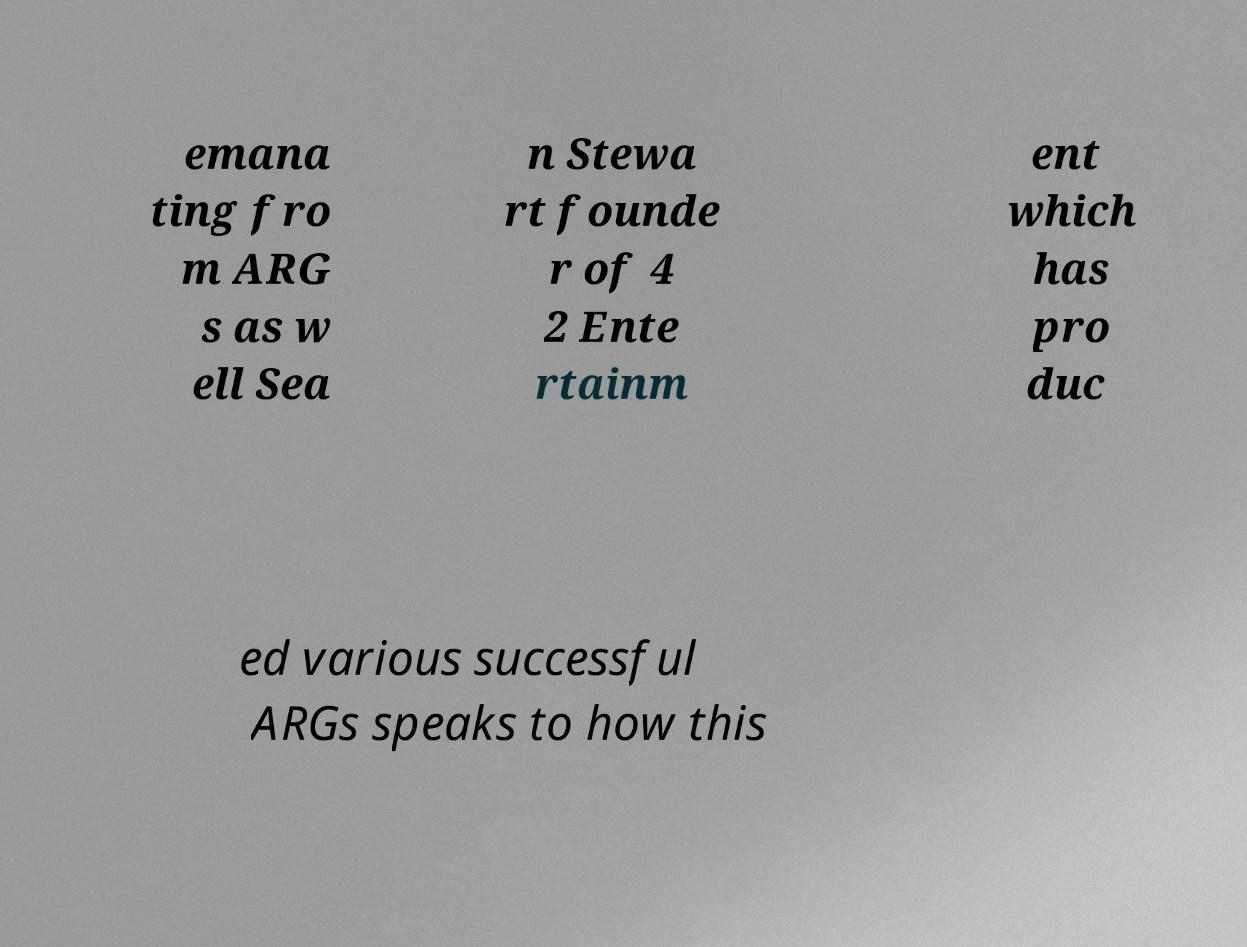Please identify and transcribe the text found in this image. emana ting fro m ARG s as w ell Sea n Stewa rt founde r of 4 2 Ente rtainm ent which has pro duc ed various successful ARGs speaks to how this 